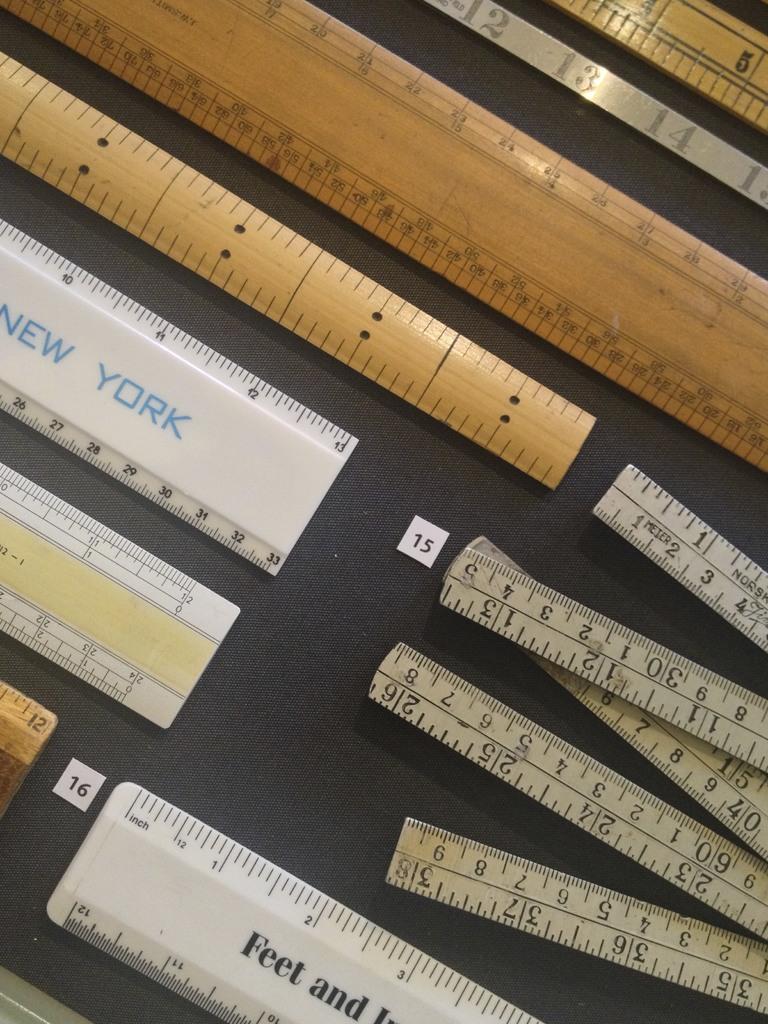Where is the ruler from?
Make the answer very short. New york. Are the rulers in inches?
Offer a very short reply. Yes. 